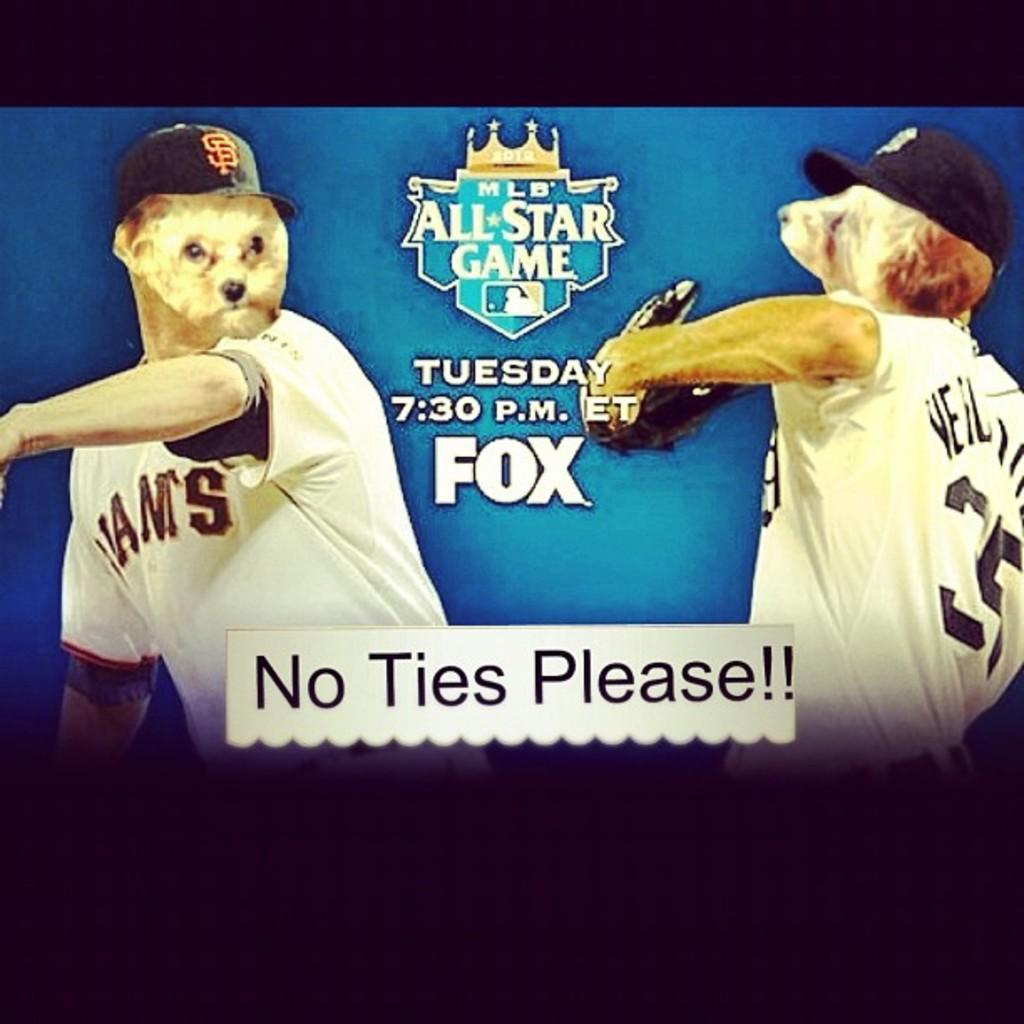<image>
Summarize the visual content of the image. a world series promo with the word Fox on it 